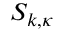<formula> <loc_0><loc_0><loc_500><loc_500>S _ { k , \kappa }</formula> 